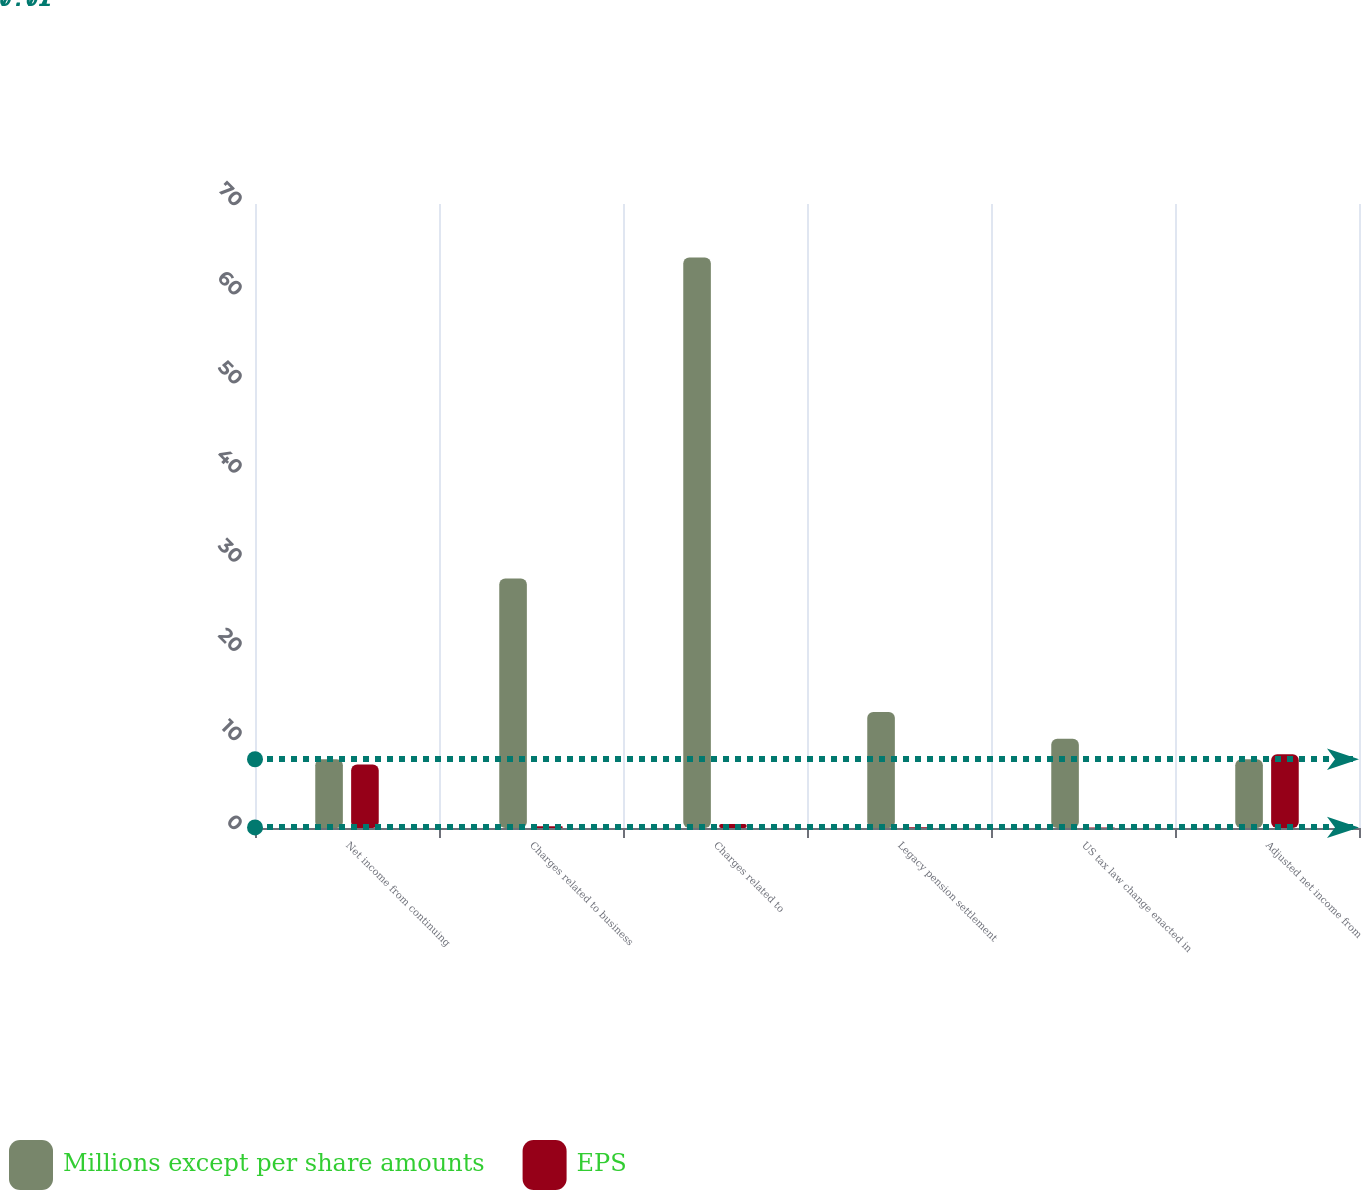Convert chart. <chart><loc_0><loc_0><loc_500><loc_500><stacked_bar_chart><ecel><fcel>Net income from continuing<fcel>Charges related to business<fcel>Charges related to<fcel>Legacy pension settlement<fcel>US tax law change enacted in<fcel>Adjusted net income from<nl><fcel>Millions except per share amounts<fcel>7.705<fcel>28<fcel>64<fcel>13<fcel>10<fcel>7.705<nl><fcel>EPS<fcel>7.13<fcel>0.19<fcel>0.44<fcel>0.09<fcel>0.07<fcel>8.28<nl></chart> 